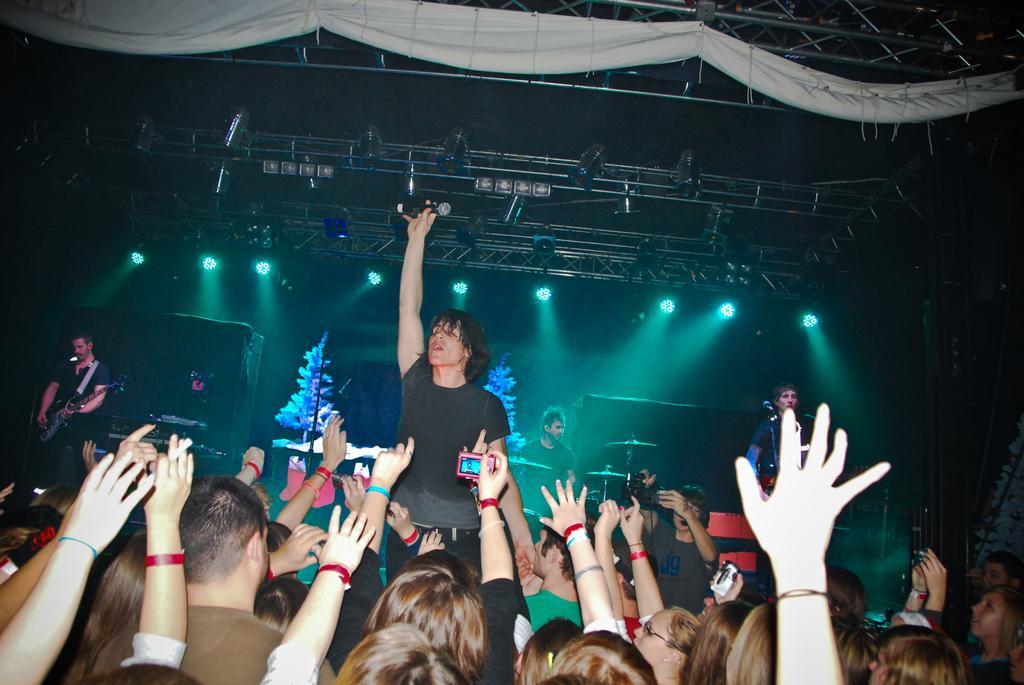Could you give a brief overview of what you see in this image? In the picture we can see inside the pub with some people enjoying the music and raising their hands and in the background, we can see a man standing and raising his hand, in his hand, we can see a microphone and behind him we can see some people are playing guitars and orchestra and to the ceiling we can see some lights to the iron rods. 